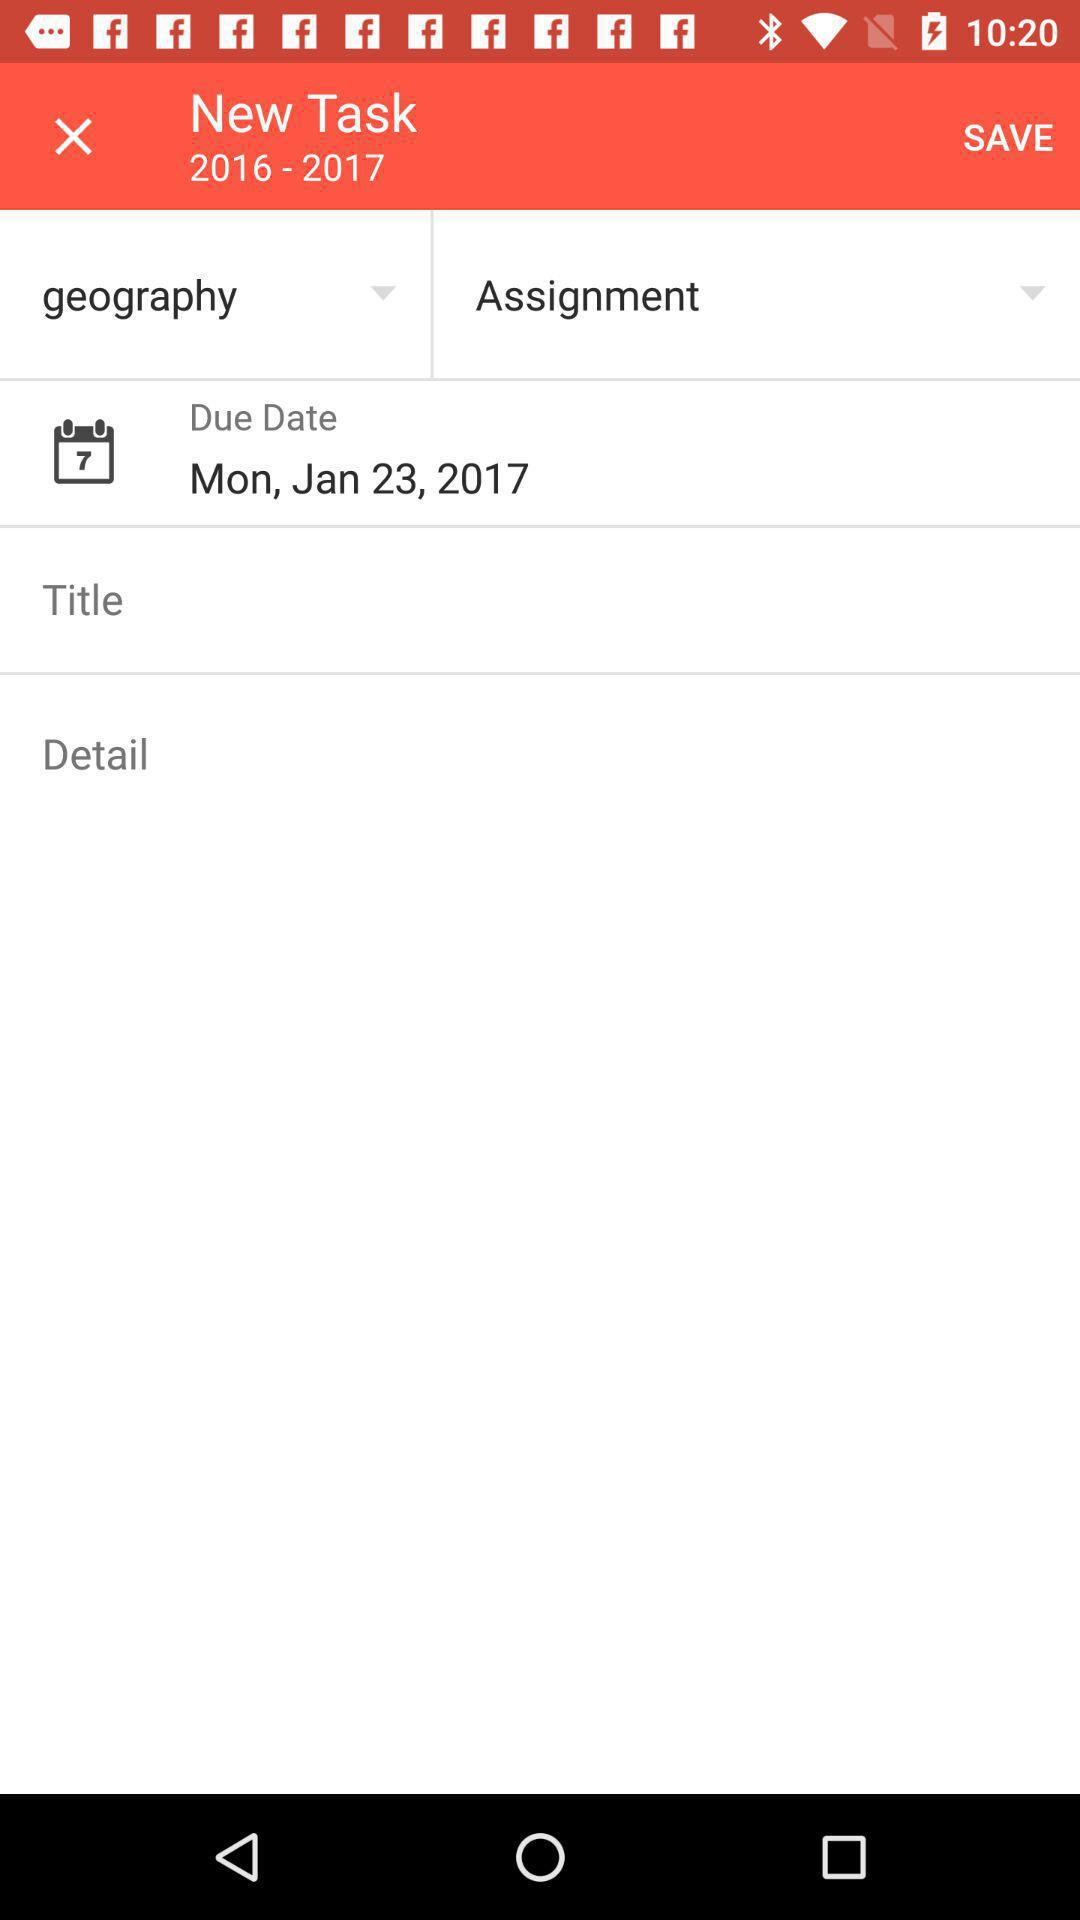What year's new task is it? The year of new task is 2016 - 2017. 